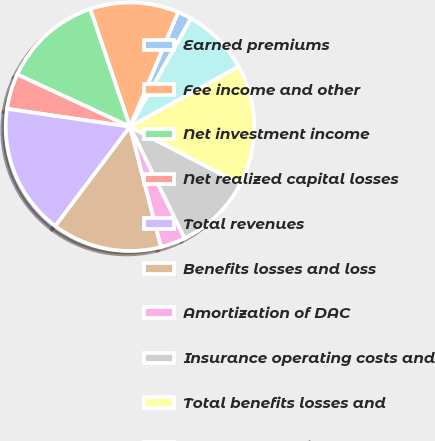<chart> <loc_0><loc_0><loc_500><loc_500><pie_chart><fcel>Earned premiums<fcel>Fee income and other<fcel>Net investment income<fcel>Net realized capital losses<fcel>Total revenues<fcel>Benefits losses and loss<fcel>Amortization of DAC<fcel>Insurance operating costs and<fcel>Total benefits losses and<fcel>Income before income taxes<nl><fcel>1.85%<fcel>11.52%<fcel>12.9%<fcel>4.61%<fcel>17.05%<fcel>14.28%<fcel>3.23%<fcel>10.14%<fcel>15.67%<fcel>8.76%<nl></chart> 